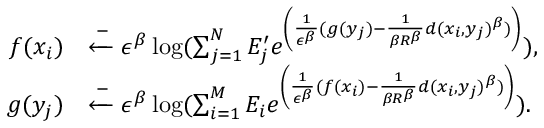<formula> <loc_0><loc_0><loc_500><loc_500>\begin{array} { r l } { f ( x _ { i } ) } & { \xleftarrow - \epsilon ^ { \beta } \log ( \sum _ { j = 1 } ^ { N } E _ { j } ^ { \prime } e ^ { \left ( \frac { 1 } { \epsilon ^ { \beta } } ( g ( y _ { j } ) - \frac { 1 } { \beta R ^ { \beta } } d ( x _ { i } , y _ { j } ) ^ { \beta } ) \right ) } ) , } \\ { g ( y _ { j } ) } & { \xleftarrow - \epsilon ^ { \beta } \log ( \sum _ { i = 1 } ^ { M } E _ { i } e ^ { \left ( \frac { 1 } { \epsilon ^ { \beta } } ( f ( x _ { i } ) - \frac { 1 } { \beta R ^ { \beta } } d ( x _ { i } , y _ { j } ) ^ { \beta } ) \right ) } ) . } \end{array}</formula> 